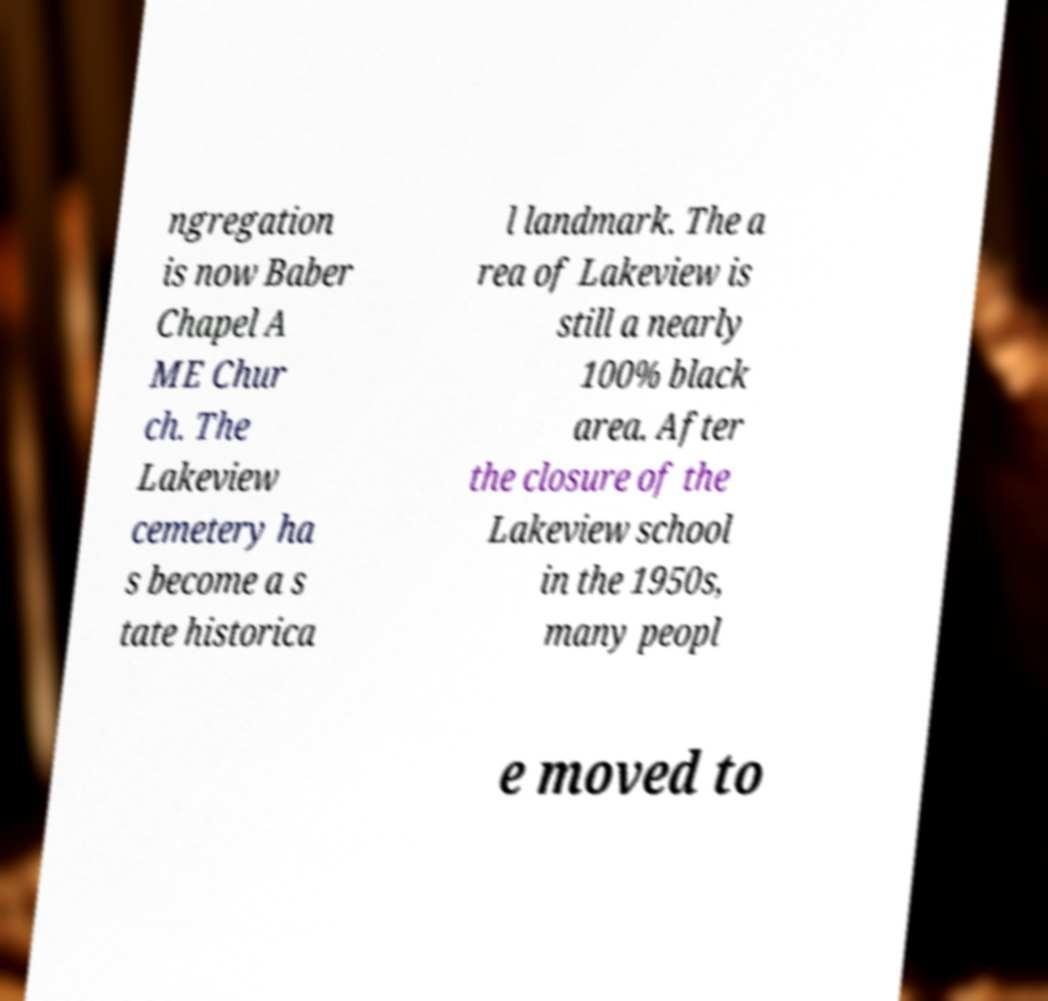I need the written content from this picture converted into text. Can you do that? ngregation is now Baber Chapel A ME Chur ch. The Lakeview cemetery ha s become a s tate historica l landmark. The a rea of Lakeview is still a nearly 100% black area. After the closure of the Lakeview school in the 1950s, many peopl e moved to 